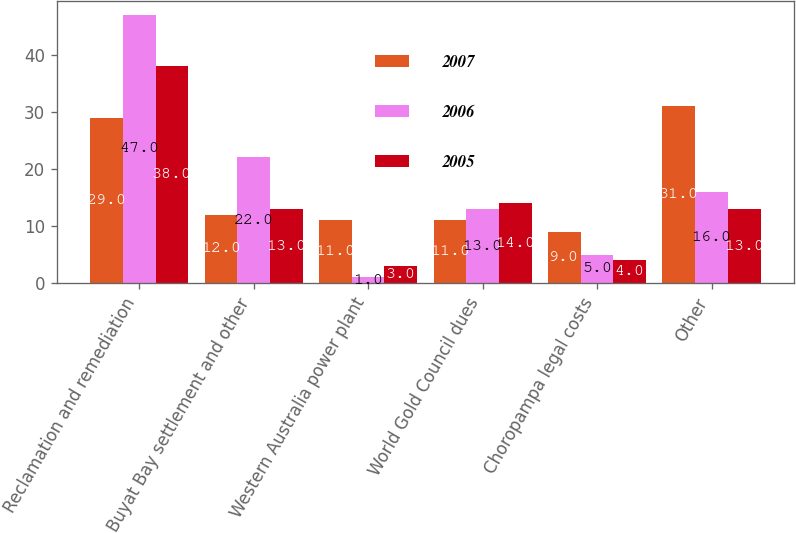Convert chart to OTSL. <chart><loc_0><loc_0><loc_500><loc_500><stacked_bar_chart><ecel><fcel>Reclamation and remediation<fcel>Buyat Bay settlement and other<fcel>Western Australia power plant<fcel>World Gold Council dues<fcel>Choropampa legal costs<fcel>Other<nl><fcel>2007<fcel>29<fcel>12<fcel>11<fcel>11<fcel>9<fcel>31<nl><fcel>2006<fcel>47<fcel>22<fcel>1<fcel>13<fcel>5<fcel>16<nl><fcel>2005<fcel>38<fcel>13<fcel>3<fcel>14<fcel>4<fcel>13<nl></chart> 